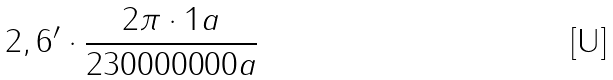<formula> <loc_0><loc_0><loc_500><loc_500>2 , 6 ^ { \prime } \cdot \frac { 2 \pi \cdot 1 a } { 2 3 0 0 0 0 0 0 0 a }</formula> 